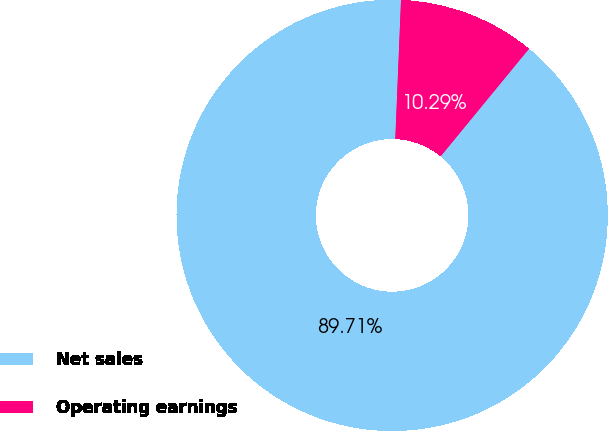<chart> <loc_0><loc_0><loc_500><loc_500><pie_chart><fcel>Net sales<fcel>Operating earnings<nl><fcel>89.71%<fcel>10.29%<nl></chart> 